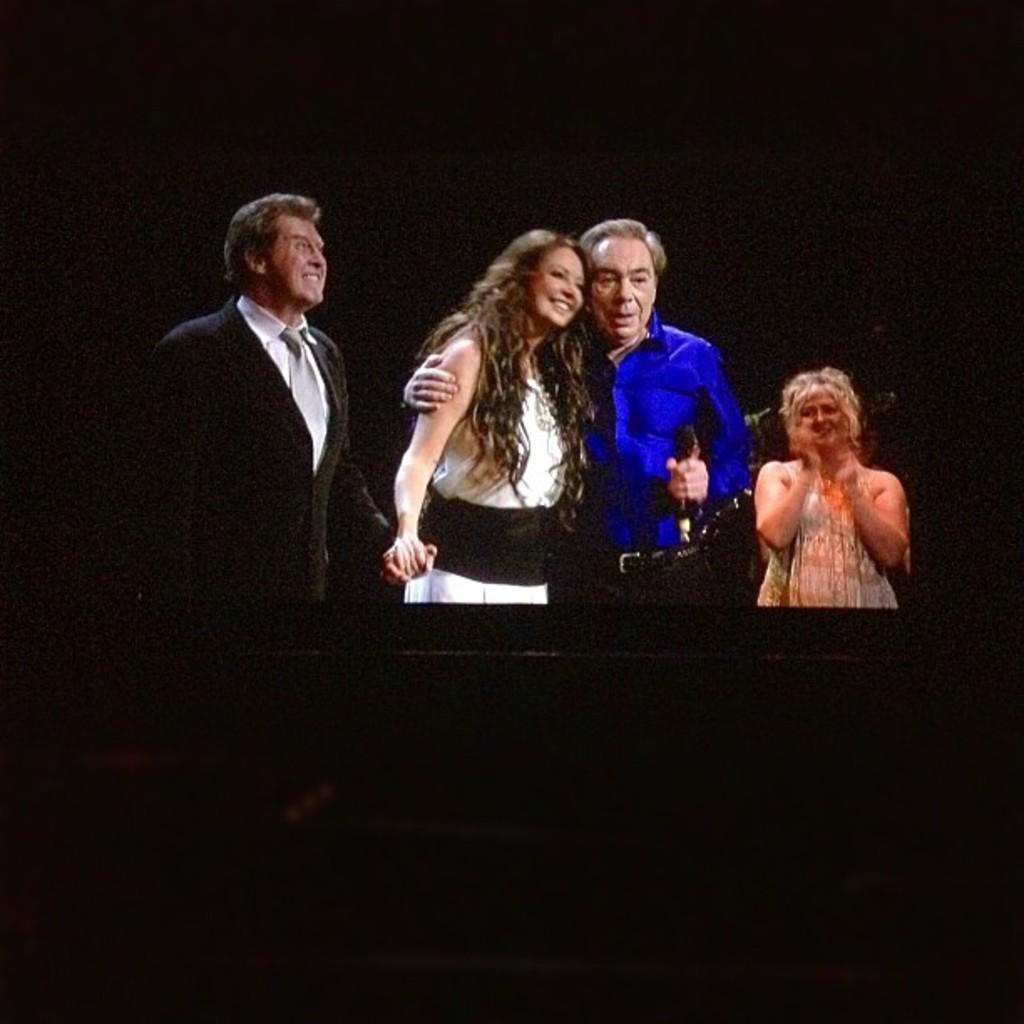What is happening in the image? There are people standing in the image. What can be observed about the lighting in the image? The background of the image is dark. What type of rose is being used as a prop by one of the people in the image? There is no rose present in the image; it only features people standing in a dark background. 